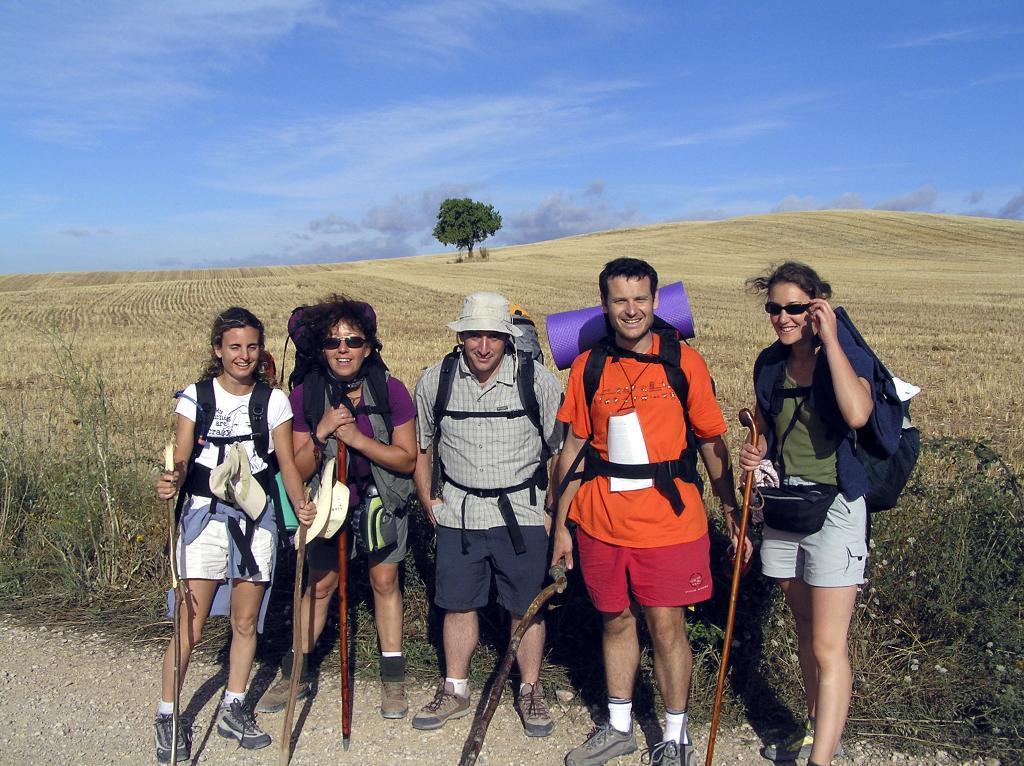Please provide a concise description of this image. In this image i can see three women and two man standing, wearing a bag and holding sticks in their hand at the back ground i can see a small plant , a tree, sky. 